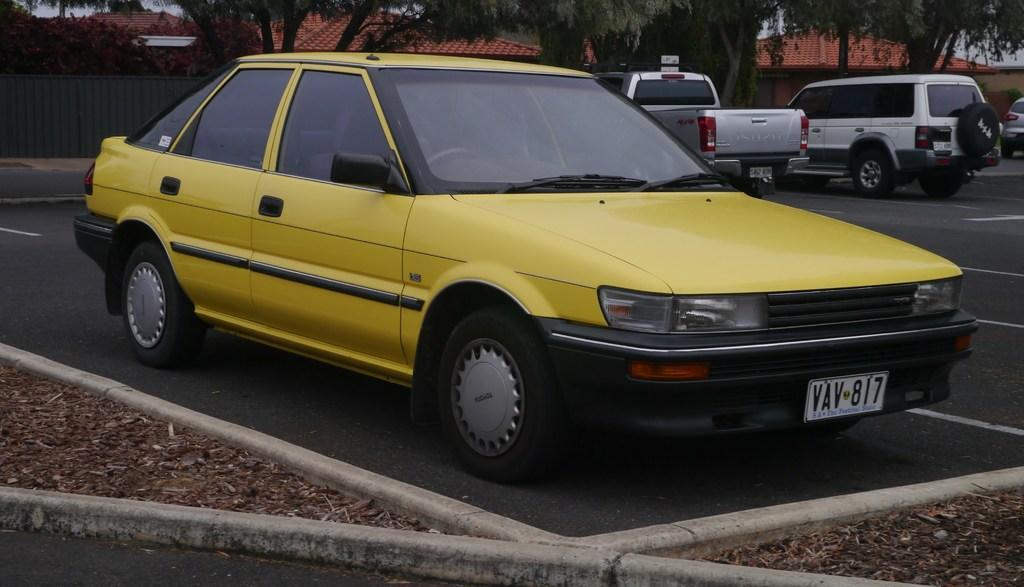Please provide a concise description of this image. In this image we can see a yellow color car parked here. Here we can see dry leaves. In the background, we can see a few more cars parked on the road, fence, trees and houses. 